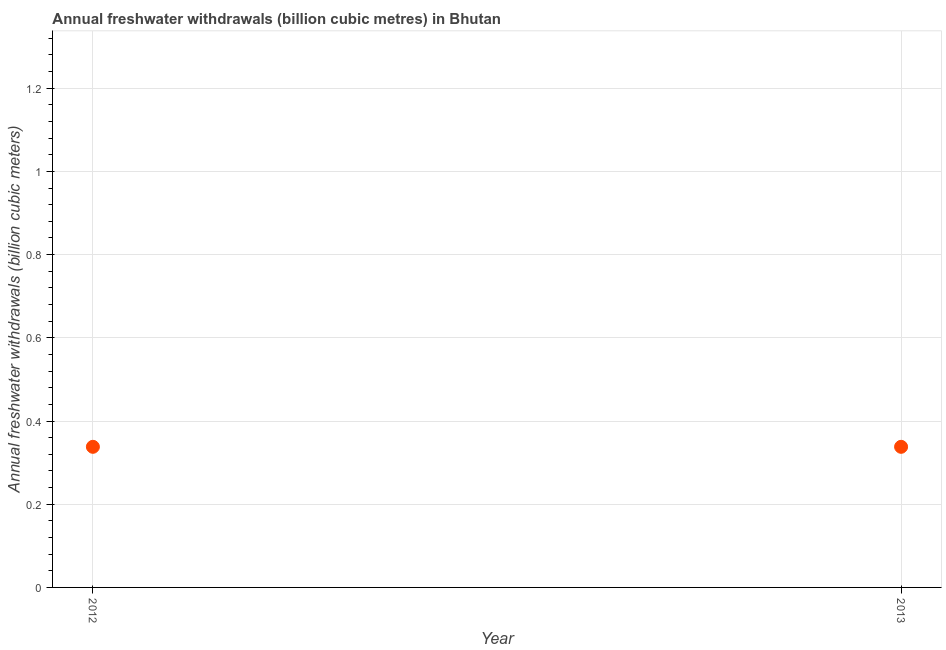What is the annual freshwater withdrawals in 2013?
Your answer should be very brief. 0.34. Across all years, what is the maximum annual freshwater withdrawals?
Your response must be concise. 0.34. Across all years, what is the minimum annual freshwater withdrawals?
Make the answer very short. 0.34. In which year was the annual freshwater withdrawals minimum?
Ensure brevity in your answer.  2012. What is the sum of the annual freshwater withdrawals?
Give a very brief answer. 0.68. What is the difference between the annual freshwater withdrawals in 2012 and 2013?
Ensure brevity in your answer.  0. What is the average annual freshwater withdrawals per year?
Make the answer very short. 0.34. What is the median annual freshwater withdrawals?
Make the answer very short. 0.34. Do a majority of the years between 2013 and 2012 (inclusive) have annual freshwater withdrawals greater than 0.92 billion cubic meters?
Provide a short and direct response. No. What is the ratio of the annual freshwater withdrawals in 2012 to that in 2013?
Give a very brief answer. 1. Is the annual freshwater withdrawals in 2012 less than that in 2013?
Keep it short and to the point. No. How many years are there in the graph?
Offer a terse response. 2. Are the values on the major ticks of Y-axis written in scientific E-notation?
Your answer should be very brief. No. What is the title of the graph?
Your answer should be very brief. Annual freshwater withdrawals (billion cubic metres) in Bhutan. What is the label or title of the Y-axis?
Your answer should be compact. Annual freshwater withdrawals (billion cubic meters). What is the Annual freshwater withdrawals (billion cubic meters) in 2012?
Ensure brevity in your answer.  0.34. What is the Annual freshwater withdrawals (billion cubic meters) in 2013?
Offer a terse response. 0.34. What is the difference between the Annual freshwater withdrawals (billion cubic meters) in 2012 and 2013?
Make the answer very short. 0. What is the ratio of the Annual freshwater withdrawals (billion cubic meters) in 2012 to that in 2013?
Keep it short and to the point. 1. 